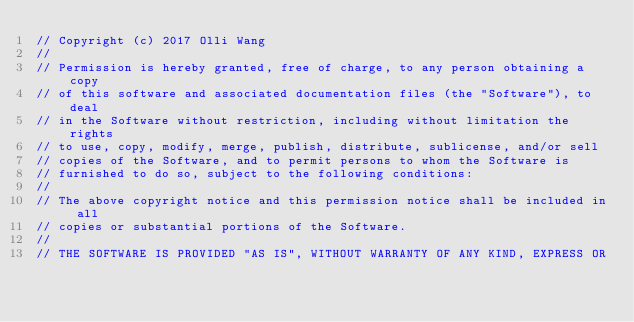<code> <loc_0><loc_0><loc_500><loc_500><_ObjectiveC_>// Copyright (c) 2017 Olli Wang
//
// Permission is hereby granted, free of charge, to any person obtaining a copy
// of this software and associated documentation files (the "Software"), to deal
// in the Software without restriction, including without limitation the rights
// to use, copy, modify, merge, publish, distribute, sublicense, and/or sell
// copies of the Software, and to permit persons to whom the Software is
// furnished to do so, subject to the following conditions:
//
// The above copyright notice and this permission notice shall be included in all
// copies or substantial portions of the Software.
//
// THE SOFTWARE IS PROVIDED "AS IS", WITHOUT WARRANTY OF ANY KIND, EXPRESS OR</code> 